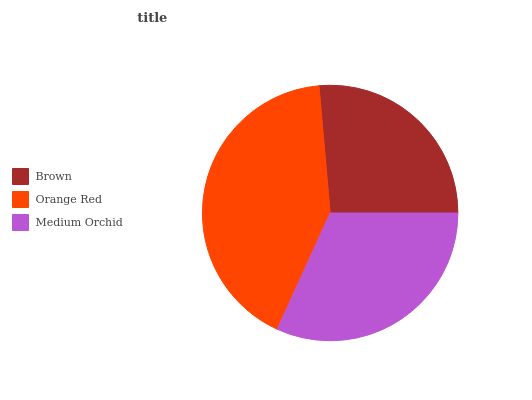Is Brown the minimum?
Answer yes or no. Yes. Is Orange Red the maximum?
Answer yes or no. Yes. Is Medium Orchid the minimum?
Answer yes or no. No. Is Medium Orchid the maximum?
Answer yes or no. No. Is Orange Red greater than Medium Orchid?
Answer yes or no. Yes. Is Medium Orchid less than Orange Red?
Answer yes or no. Yes. Is Medium Orchid greater than Orange Red?
Answer yes or no. No. Is Orange Red less than Medium Orchid?
Answer yes or no. No. Is Medium Orchid the high median?
Answer yes or no. Yes. Is Medium Orchid the low median?
Answer yes or no. Yes. Is Orange Red the high median?
Answer yes or no. No. Is Orange Red the low median?
Answer yes or no. No. 